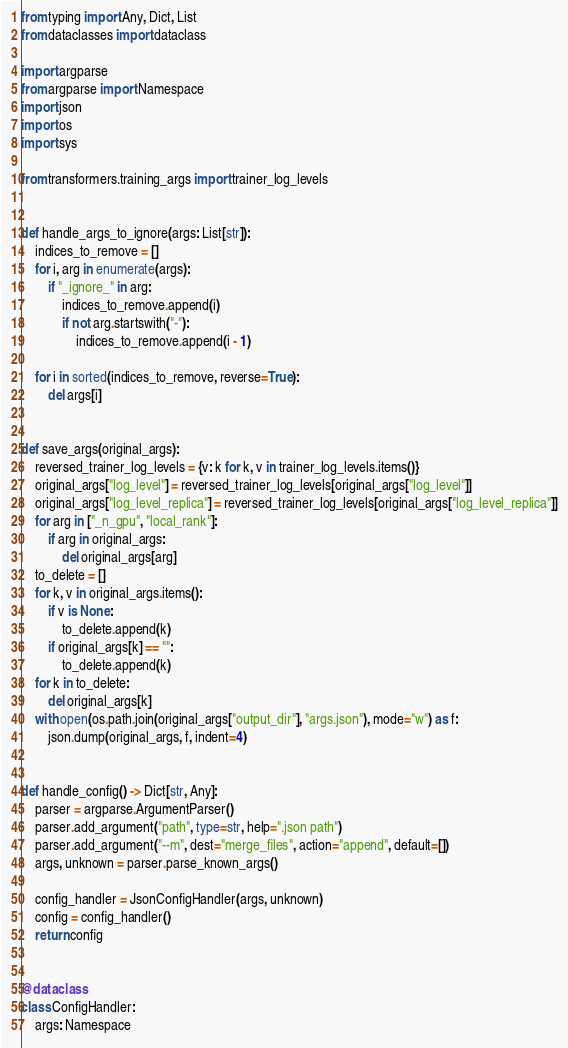<code> <loc_0><loc_0><loc_500><loc_500><_Python_>from typing import Any, Dict, List
from dataclasses import dataclass

import argparse
from argparse import Namespace
import json
import os
import sys

from transformers.training_args import trainer_log_levels


def handle_args_to_ignore(args: List[str]):
    indices_to_remove = []
    for i, arg in enumerate(args):
        if "_ignore_" in arg:
            indices_to_remove.append(i)
            if not arg.startswith("-"):
                indices_to_remove.append(i - 1)

    for i in sorted(indices_to_remove, reverse=True):
        del args[i]


def save_args(original_args):
    reversed_trainer_log_levels = {v: k for k, v in trainer_log_levels.items()}
    original_args["log_level"] = reversed_trainer_log_levels[original_args["log_level"]]
    original_args["log_level_replica"] = reversed_trainer_log_levels[original_args["log_level_replica"]]
    for arg in ["_n_gpu", "local_rank"]:
        if arg in original_args:
            del original_args[arg]
    to_delete = []
    for k, v in original_args.items():
        if v is None:
            to_delete.append(k)
        if original_args[k] == "":
            to_delete.append(k)
    for k in to_delete:
        del original_args[k]
    with open(os.path.join(original_args["output_dir"], "args.json"), mode="w") as f:
        json.dump(original_args, f, indent=4)


def handle_config() -> Dict[str, Any]:
    parser = argparse.ArgumentParser()
    parser.add_argument("path", type=str, help=".json path")
    parser.add_argument("--m", dest="merge_files", action="append", default=[])
    args, unknown = parser.parse_known_args()

    config_handler = JsonConfigHandler(args, unknown)
    config = config_handler()
    return config


@dataclass
class ConfigHandler:
    args: Namespace</code> 